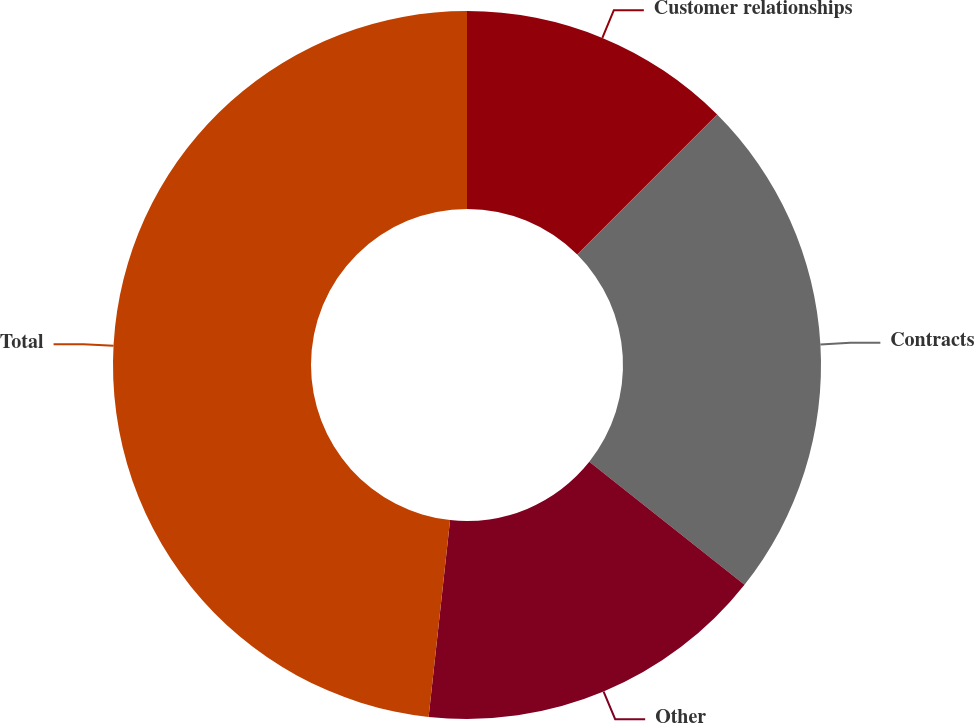Convert chart to OTSL. <chart><loc_0><loc_0><loc_500><loc_500><pie_chart><fcel>Customer relationships<fcel>Contracts<fcel>Other<fcel>Total<nl><fcel>12.49%<fcel>23.17%<fcel>16.07%<fcel>48.27%<nl></chart> 